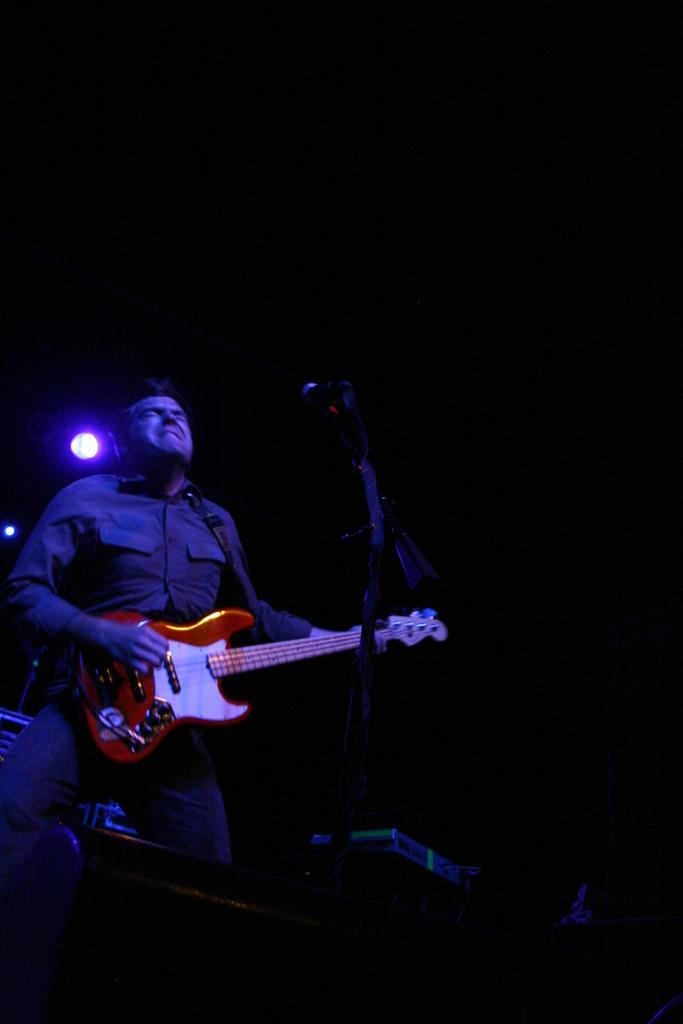Who is the main subject in the image? There is a man in the image. What is the man holding in the image? The man is holding a guitar. What object is the man standing in front of? The man is standing in front of a microphone. What can be seen in the background of the image? There is light visible in the background of the image. What type of currency is being exchanged in the image? There is no exchange of currency depicted in the image. 